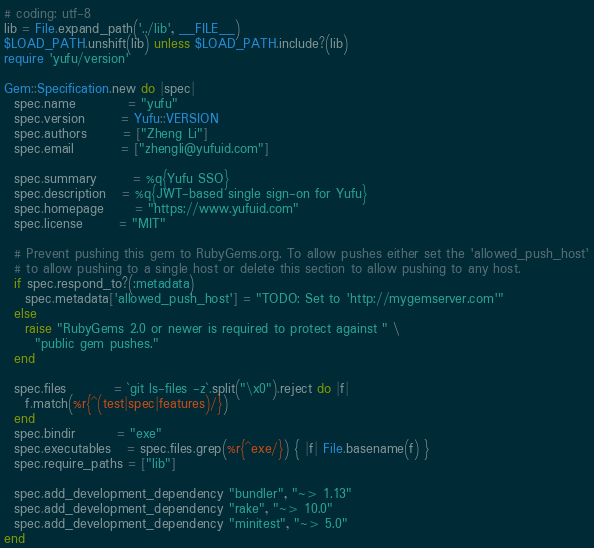<code> <loc_0><loc_0><loc_500><loc_500><_Ruby_># coding: utf-8
lib = File.expand_path('../lib', __FILE__)
$LOAD_PATH.unshift(lib) unless $LOAD_PATH.include?(lib)
require 'yufu/version'

Gem::Specification.new do |spec|
  spec.name          = "yufu"
  spec.version       = Yufu::VERSION
  spec.authors       = ["Zheng Li"]
  spec.email         = ["zhengli@yufuid.com"]

  spec.summary       = %q{Yufu SSO}
  spec.description   = %q{JWT-based single sign-on for Yufu}
  spec.homepage      = "https://www.yufuid.com"
  spec.license       = "MIT"

  # Prevent pushing this gem to RubyGems.org. To allow pushes either set the 'allowed_push_host'
  # to allow pushing to a single host or delete this section to allow pushing to any host.
  if spec.respond_to?(:metadata)
    spec.metadata['allowed_push_host'] = "TODO: Set to 'http://mygemserver.com'"
  else
    raise "RubyGems 2.0 or newer is required to protect against " \
      "public gem pushes."
  end

  spec.files         = `git ls-files -z`.split("\x0").reject do |f|
    f.match(%r{^(test|spec|features)/})
  end
  spec.bindir        = "exe"
  spec.executables   = spec.files.grep(%r{^exe/}) { |f| File.basename(f) }
  spec.require_paths = ["lib"]

  spec.add_development_dependency "bundler", "~> 1.13"
  spec.add_development_dependency "rake", "~> 10.0"
  spec.add_development_dependency "minitest", "~> 5.0"
end
</code> 